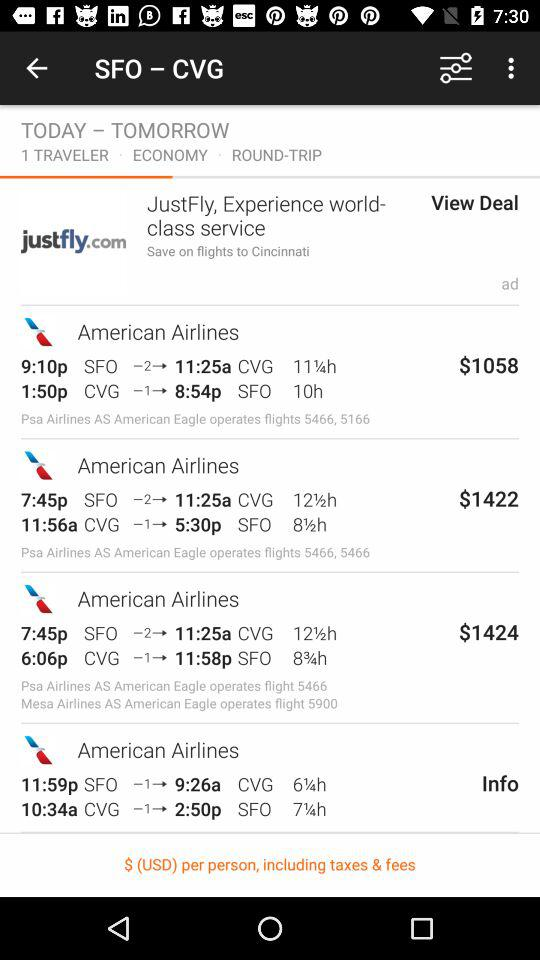How many travelers are there? There is only 1 traveler. 